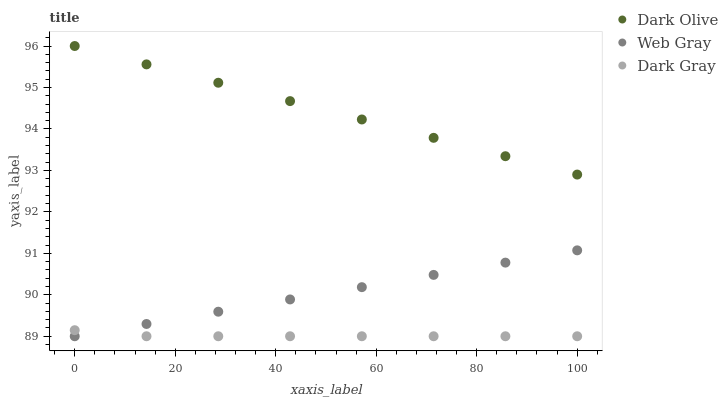Does Dark Gray have the minimum area under the curve?
Answer yes or no. Yes. Does Dark Olive have the maximum area under the curve?
Answer yes or no. Yes. Does Web Gray have the minimum area under the curve?
Answer yes or no. No. Does Web Gray have the maximum area under the curve?
Answer yes or no. No. Is Dark Olive the smoothest?
Answer yes or no. Yes. Is Dark Gray the roughest?
Answer yes or no. Yes. Is Web Gray the smoothest?
Answer yes or no. No. Is Web Gray the roughest?
Answer yes or no. No. Does Dark Gray have the lowest value?
Answer yes or no. Yes. Does Dark Olive have the lowest value?
Answer yes or no. No. Does Dark Olive have the highest value?
Answer yes or no. Yes. Does Web Gray have the highest value?
Answer yes or no. No. Is Web Gray less than Dark Olive?
Answer yes or no. Yes. Is Dark Olive greater than Web Gray?
Answer yes or no. Yes. Does Dark Gray intersect Web Gray?
Answer yes or no. Yes. Is Dark Gray less than Web Gray?
Answer yes or no. No. Is Dark Gray greater than Web Gray?
Answer yes or no. No. Does Web Gray intersect Dark Olive?
Answer yes or no. No. 